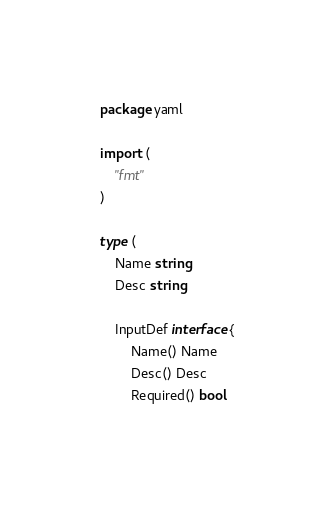Convert code to text. <code><loc_0><loc_0><loc_500><loc_500><_Go_>package yaml

import (
	"fmt"
)

type (
	Name string
	Desc string

	InputDef interface {
		Name() Name
		Desc() Desc
		Required() bool</code> 